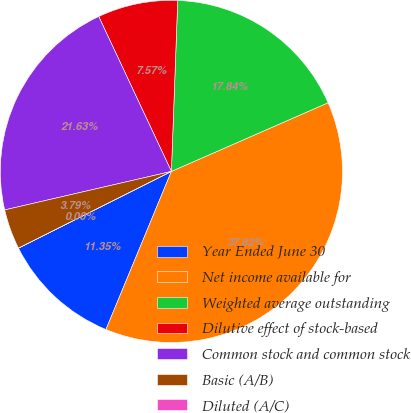Convert chart. <chart><loc_0><loc_0><loc_500><loc_500><pie_chart><fcel>Year Ended June 30<fcel>Net income available for<fcel>Weighted average outstanding<fcel>Dilutive effect of stock-based<fcel>Common stock and common stock<fcel>Basic (A/B)<fcel>Diluted (A/C)<nl><fcel>11.35%<fcel>37.82%<fcel>17.84%<fcel>7.57%<fcel>21.63%<fcel>3.79%<fcel>0.0%<nl></chart> 